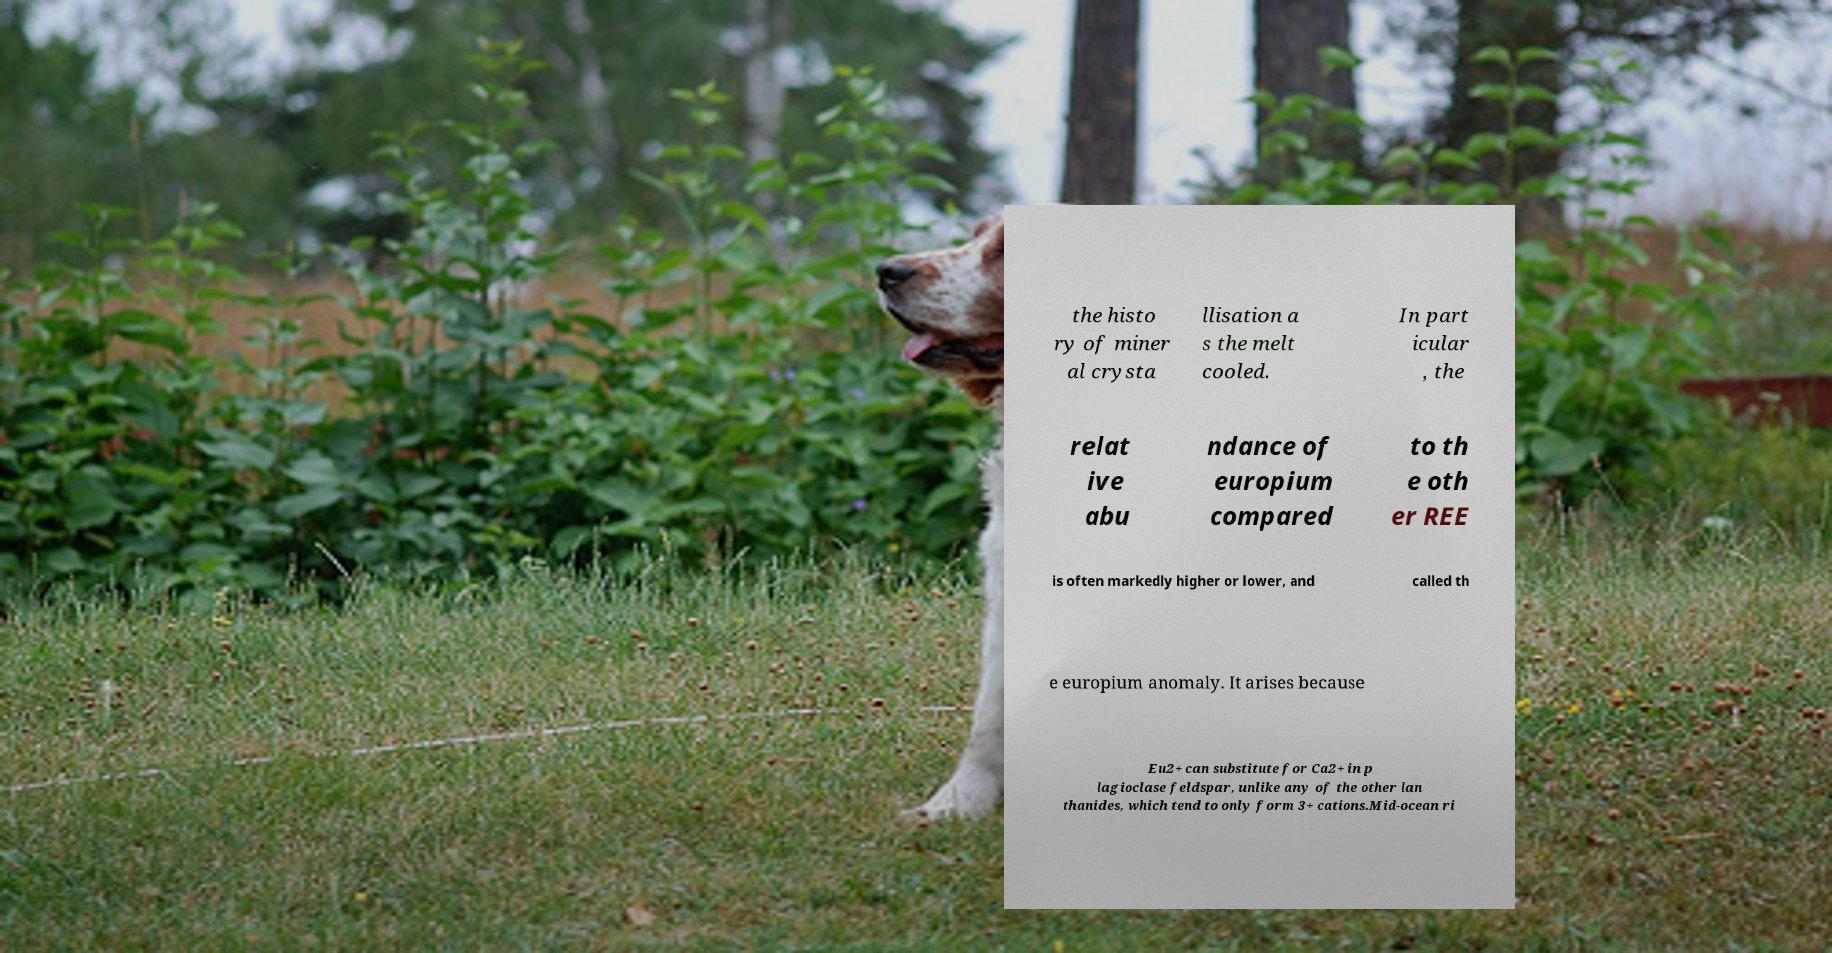Please read and relay the text visible in this image. What does it say? the histo ry of miner al crysta llisation a s the melt cooled. In part icular , the relat ive abu ndance of europium compared to th e oth er REE is often markedly higher or lower, and called th e europium anomaly. It arises because Eu2+ can substitute for Ca2+ in p lagioclase feldspar, unlike any of the other lan thanides, which tend to only form 3+ cations.Mid-ocean ri 